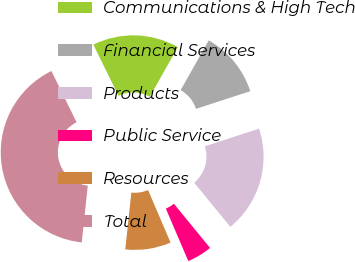Convert chart. <chart><loc_0><loc_0><loc_500><loc_500><pie_chart><fcel>Communications & High Tech<fcel>Financial Services<fcel>Products<fcel>Public Service<fcel>Resources<fcel>Total<nl><fcel>15.45%<fcel>11.79%<fcel>19.1%<fcel>4.48%<fcel>8.13%<fcel>41.04%<nl></chart> 